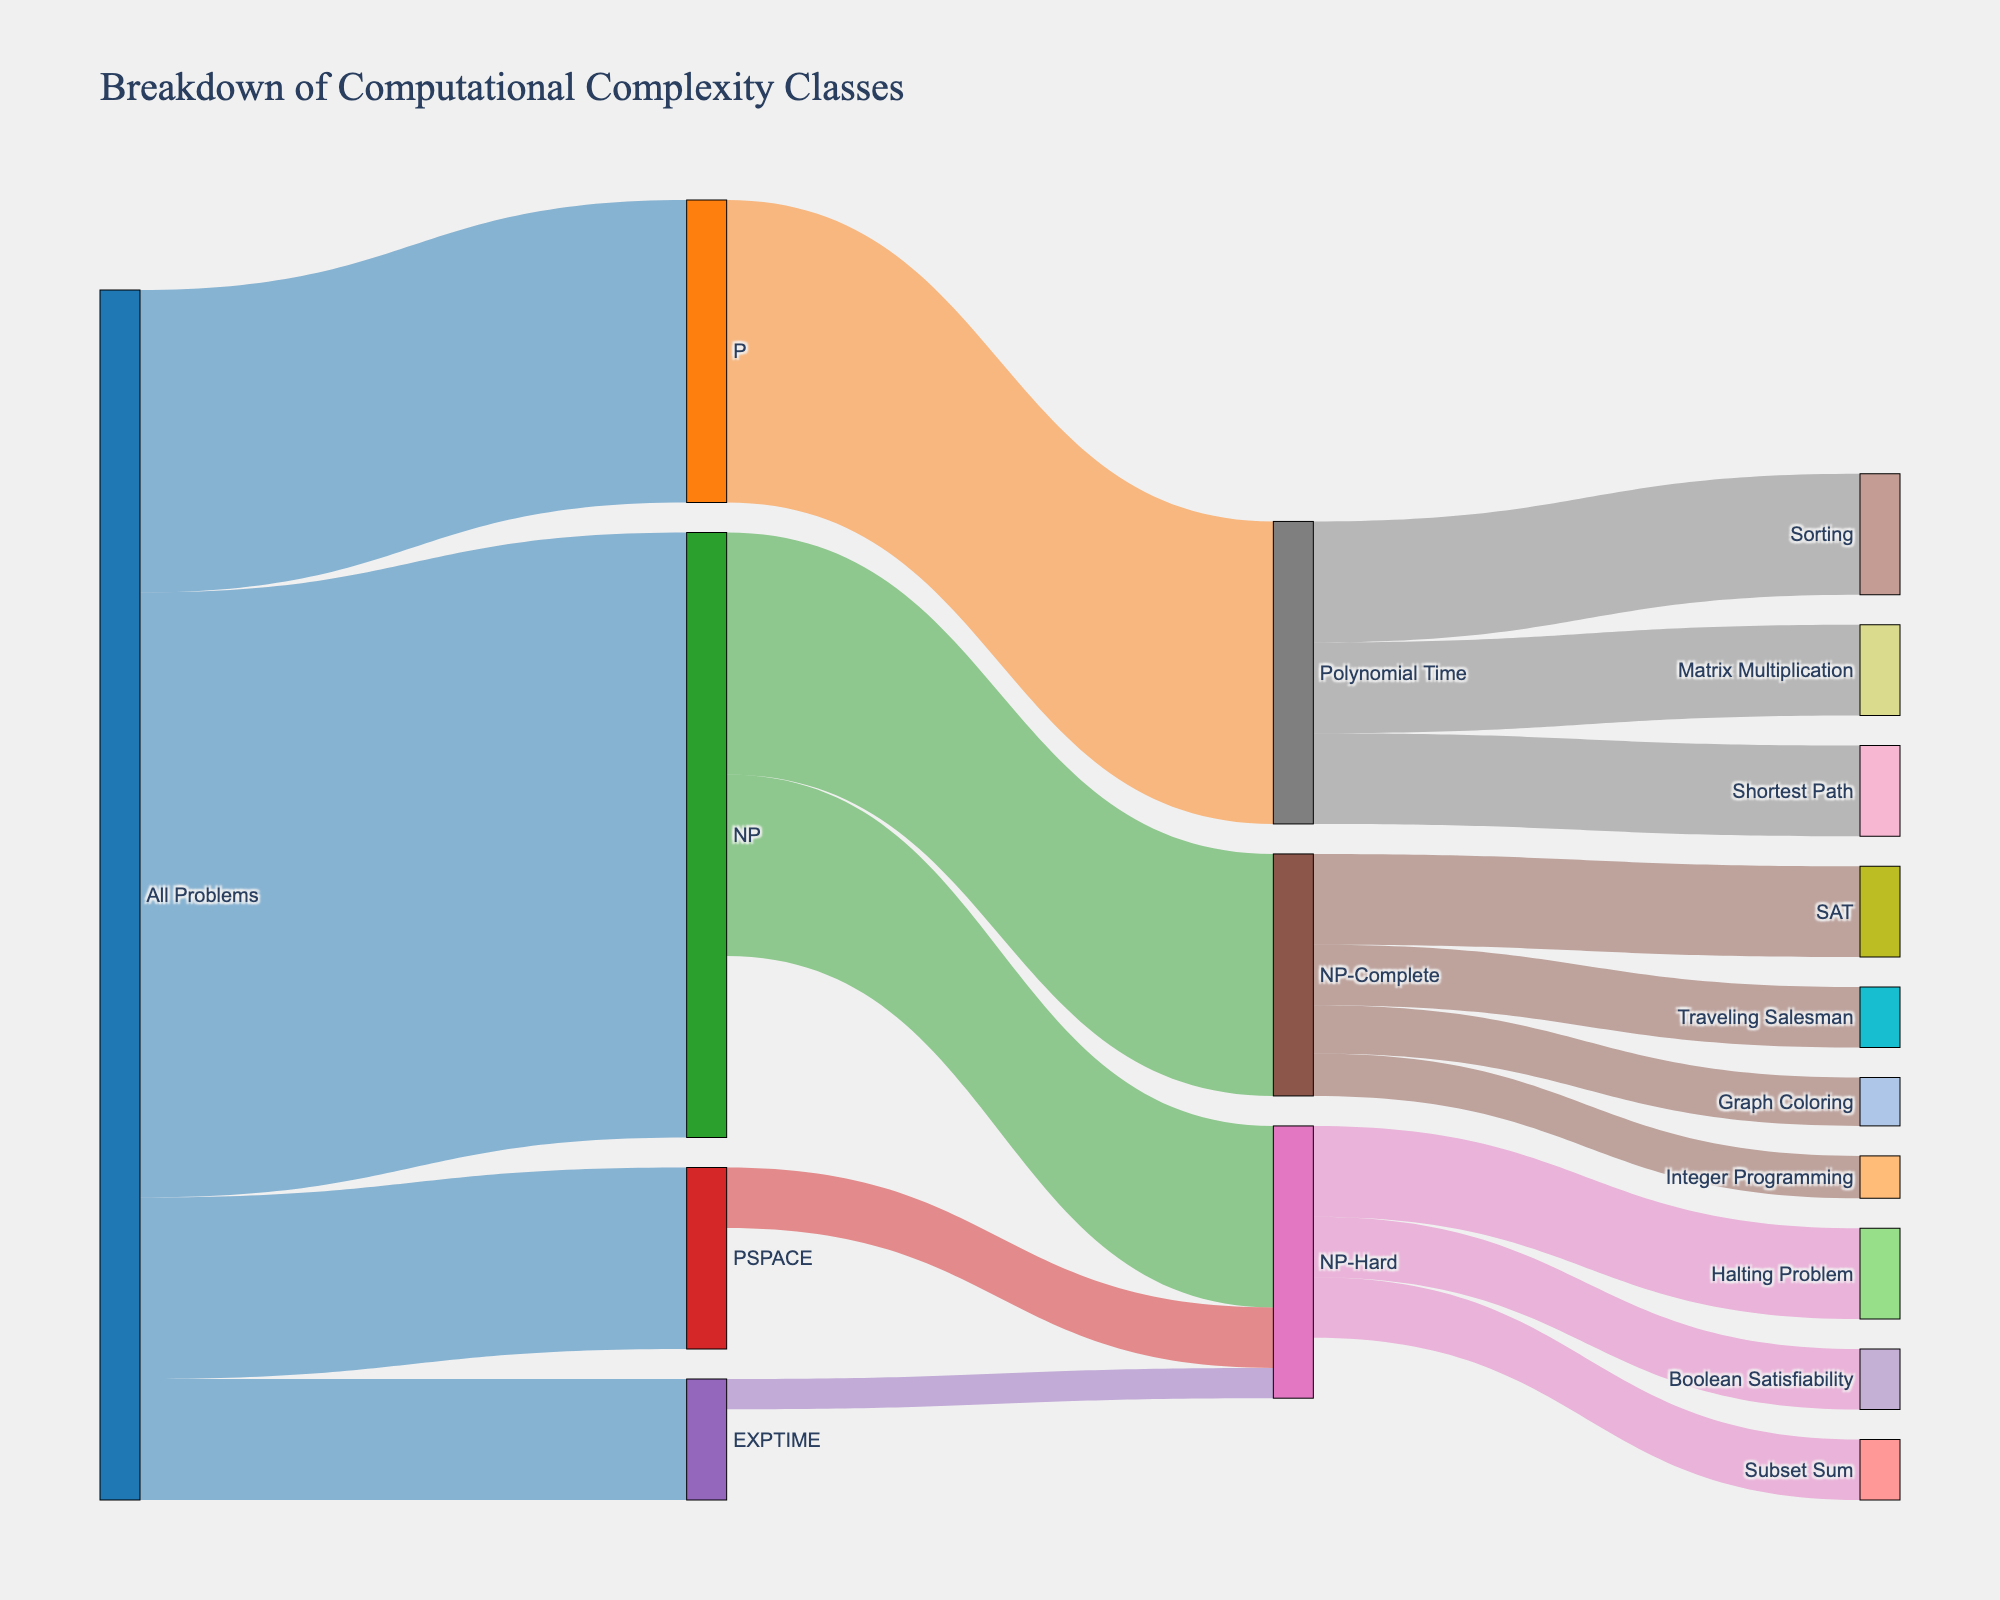what is the title of the figure? The title is mentioned at the top of the figure, which is generally the most prominent text.
Answer: Breakdown of Computational Complexity Classes Which class has the highest value originating from 'All Problems'? By looking at the connections from 'All Problems,' the value of each is shown. The highest value is 100.
Answer: NP How many subcategories does 'Polynomial Time' contain? Follow the connections from 'Polynomial Time'. Each connection represents a subcategory.
Answer: 3 What's the sum of values for problems in the 'NP-Complete' class? The sum involves adding the values of SAT, Traveling Salesman, Graph Coloring, and Integer Programming. That would be 15 + 10 + 8 + 7.
Answer: 40 Compare the values originating from 'NP' and 'PSPACE'. Which one is higher? Observe the values. 'NP' has 100 and 'PSPACE' has 30.
Answer: NP What's the difference in value between 'Sorting' and 'Subset Sum'? The values are shown next to the connections. Subtract the two values: Sorting (20) - Subset Sum (10).
Answer: 10 Which subcategory of 'Polynomial Time' has the least value? Among the connections from 'Polynomial Time,' compare the values: Sorting, Shortest Path, and Matrix Multiplication. Matrix Multiplication (15) is the lowest.
Answer: Matrix Multiplication Which categories are at the intersection of 'NP' and 'NP-Hard'? The figure shows connections where 'NP' and 'NP-Hard' overlap in terms of values.
Answer: NP-Complete How many total connections are there from 'NP'? Count all connections going out from 'NP', including to NP-Complete and NP-Hard.
Answer: 2 What is the sum of all values originating from 'EXPTIME'? Sum all values that directly originate from the 'EXPTIME' node. There is only one: NP-Hard (5).
Answer: 5 